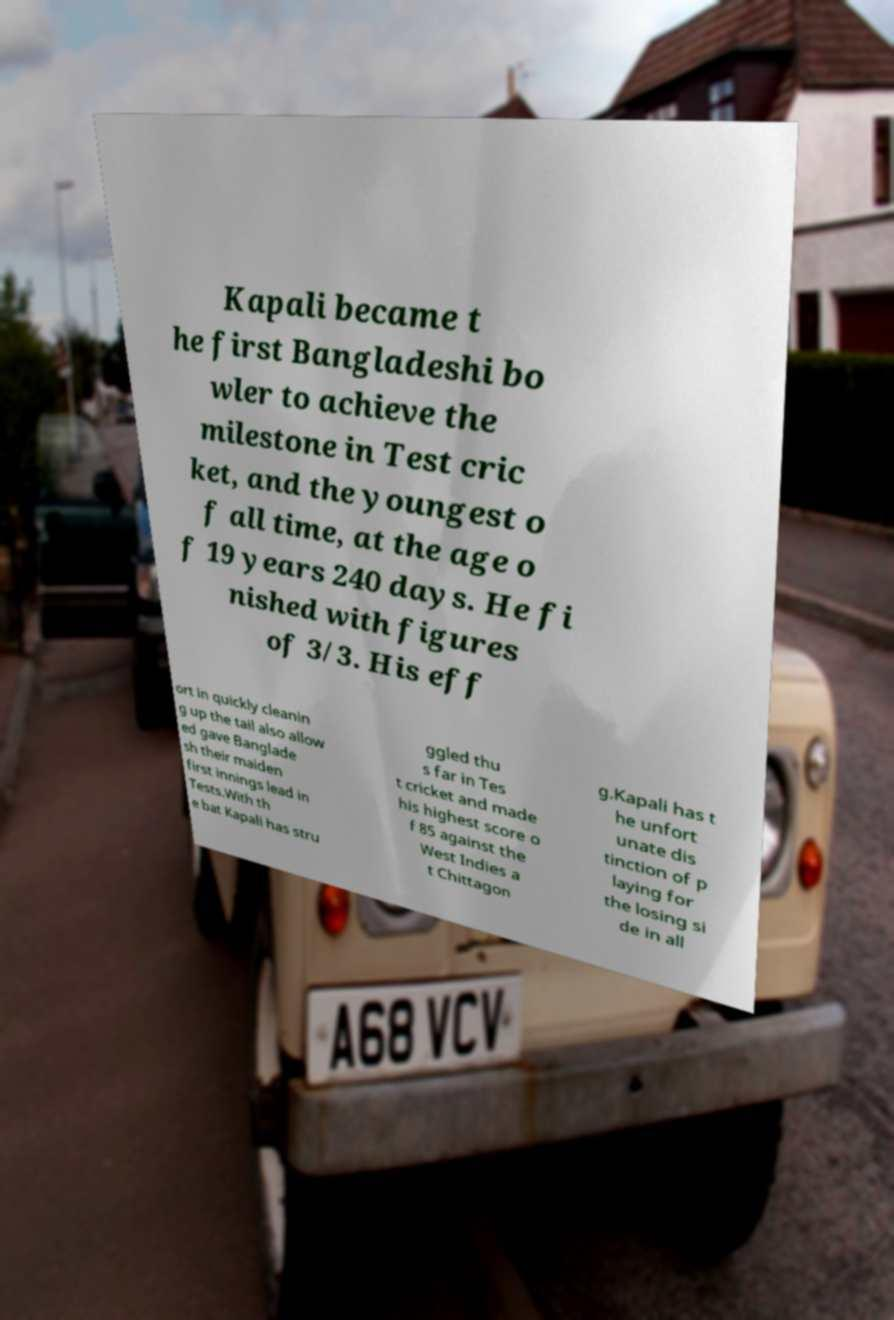There's text embedded in this image that I need extracted. Can you transcribe it verbatim? Kapali became t he first Bangladeshi bo wler to achieve the milestone in Test cric ket, and the youngest o f all time, at the age o f 19 years 240 days. He fi nished with figures of 3/3. His eff ort in quickly cleanin g up the tail also allow ed gave Banglade sh their maiden first innings lead in Tests.With th e bat Kapali has stru ggled thu s far in Tes t cricket and made his highest score o f 85 against the West Indies a t Chittagon g.Kapali has t he unfort unate dis tinction of p laying for the losing si de in all 